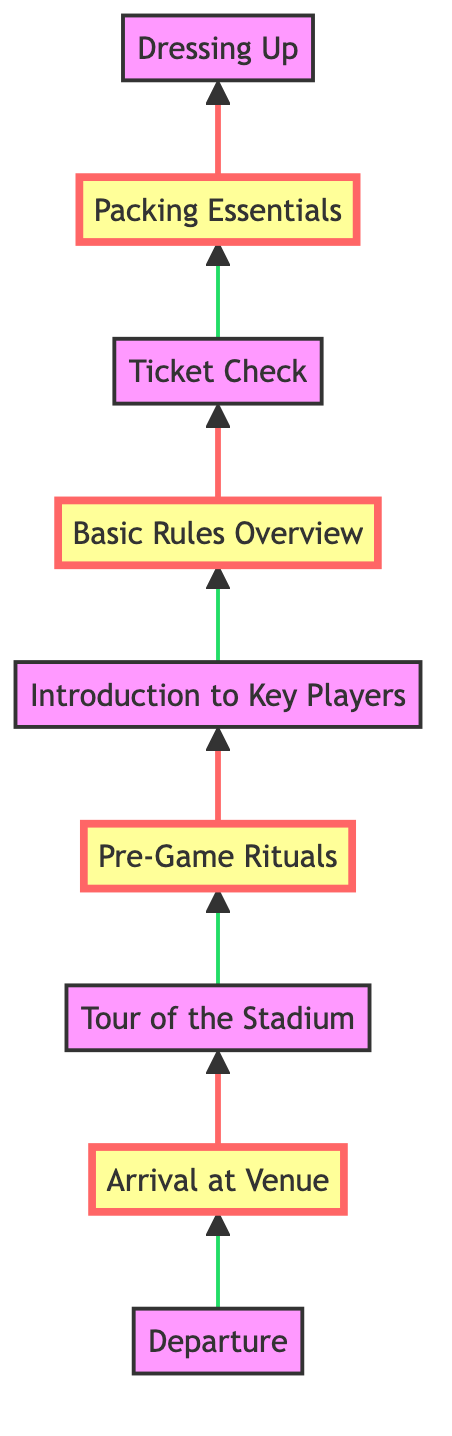What is the first step in the preparation process? The diagram indicates that the first step is "Departure," which is the starting point of the flow chart, representing the intention to leave home for the game.
Answer: Departure How many total steps are outlined in the diagram? By counting the nodes listed in the flow chart, we identify a total of eight steps from the bottom to the top of the diagram, showing the sequential preparation process.
Answer: 8 Which step comes immediately before "Arrival at Venue"? According to the flow chart, the step right before "Arrival at Venue" is "Ticket Check," which ensures that tickets are in hand before reaching the venue.
Answer: Ticket Check What must be packed before dressing up? The flow chart shows that "Packing Essentials" is the step that occurs before "Dressing Up," indicating that essentials should be ready before dressing in team gear.
Answer: Packing Essentials What is the main focus of "Basic Rules Overview"? The "Basic Rules Overview" step provides a rundown of football rules and key positions to help the child understand the game, serving as an educational precursor to the game experience.
Answer: Football rules and key positions What is the importance of the "Dressing Up" step? "Dressing Up" emphasizes the significance of wearing Miami Hurricanes gear to promote team spirit, making it a key part of preparing for the game day experience.
Answer: Team spirit Which steps in the diagram are marked as important? The important steps according to the visual key are "Arrival at Venue," "Pre-Game Rituals," "Basic Rules Overview," and "Packing Essentials," highlighting critical phases of preparation.
Answer: Arrival at Venue, Pre-Game Rituals, Basic Rules Overview, Packing Essentials What is the last action before the child experiences the game? The last node preceding the actual experience of the game is "Introduction to Key Players," which discusses notable players the child should be familiar with prior to seeing them play.
Answer: Introduction to Key Players What action occurs directly after arriving at the venue? Following "Arrival at Venue," the next action outlined in the diagram is "Tour of the Stadium," which prepares the child for the game environment by familiarizing them with the stadium.
Answer: Tour of the Stadium 